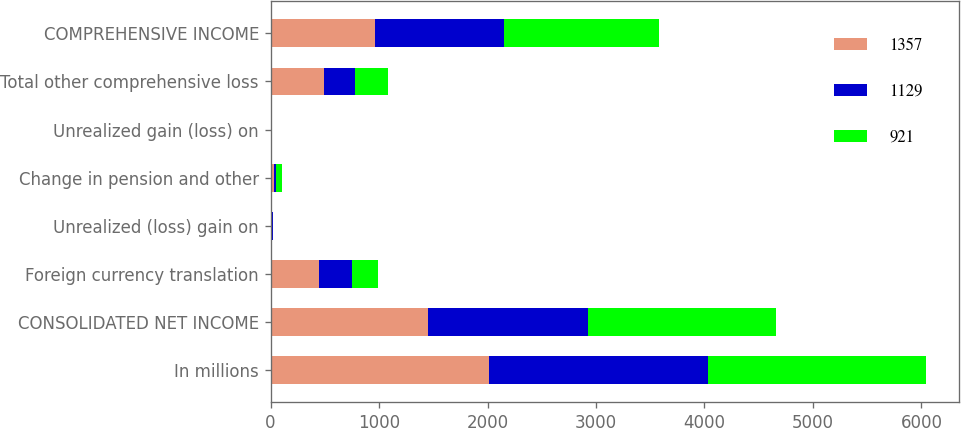<chart> <loc_0><loc_0><loc_500><loc_500><stacked_bar_chart><ecel><fcel>In millions<fcel>CONSOLIDATED NET INCOME<fcel>Foreign currency translation<fcel>Unrealized (loss) gain on<fcel>Change in pension and other<fcel>Unrealized gain (loss) on<fcel>Total other comprehensive loss<fcel>COMPREHENSIVE INCOME<nl><fcel>1357<fcel>2016<fcel>1456<fcel>448<fcel>12<fcel>31<fcel>1<fcel>490<fcel>966<nl><fcel>1129<fcel>2015<fcel>1470<fcel>305<fcel>6<fcel>15<fcel>1<fcel>285<fcel>1185<nl><fcel>921<fcel>2014<fcel>1736<fcel>234<fcel>1<fcel>58<fcel>12<fcel>305<fcel>1431<nl></chart> 